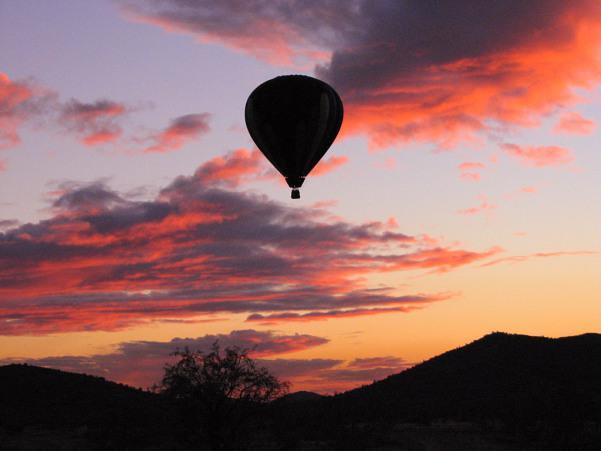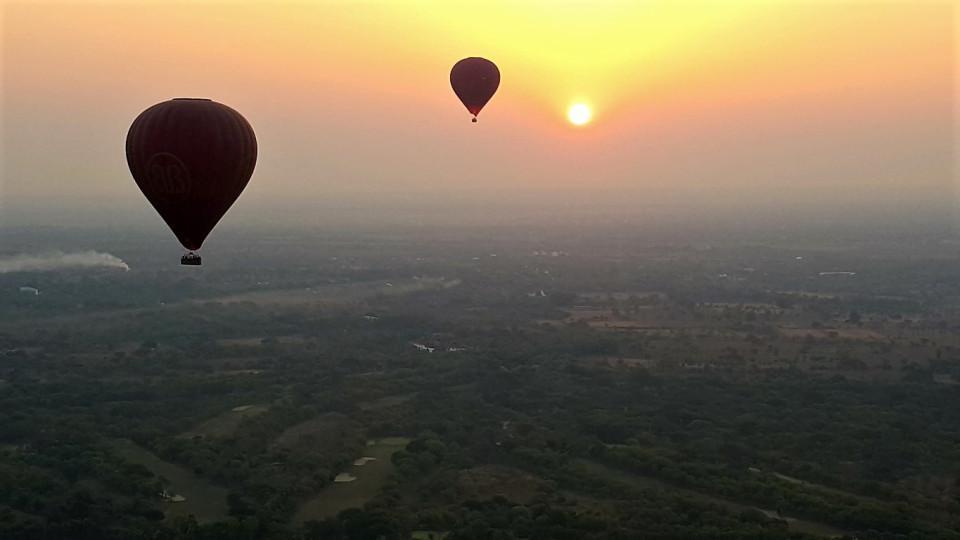The first image is the image on the left, the second image is the image on the right. Given the left and right images, does the statement "At least one image has exactly three balloons." hold true? Answer yes or no. No. The first image is the image on the left, the second image is the image on the right. Evaluate the accuracy of this statement regarding the images: "There are three hot air balloons.". Is it true? Answer yes or no. Yes. 